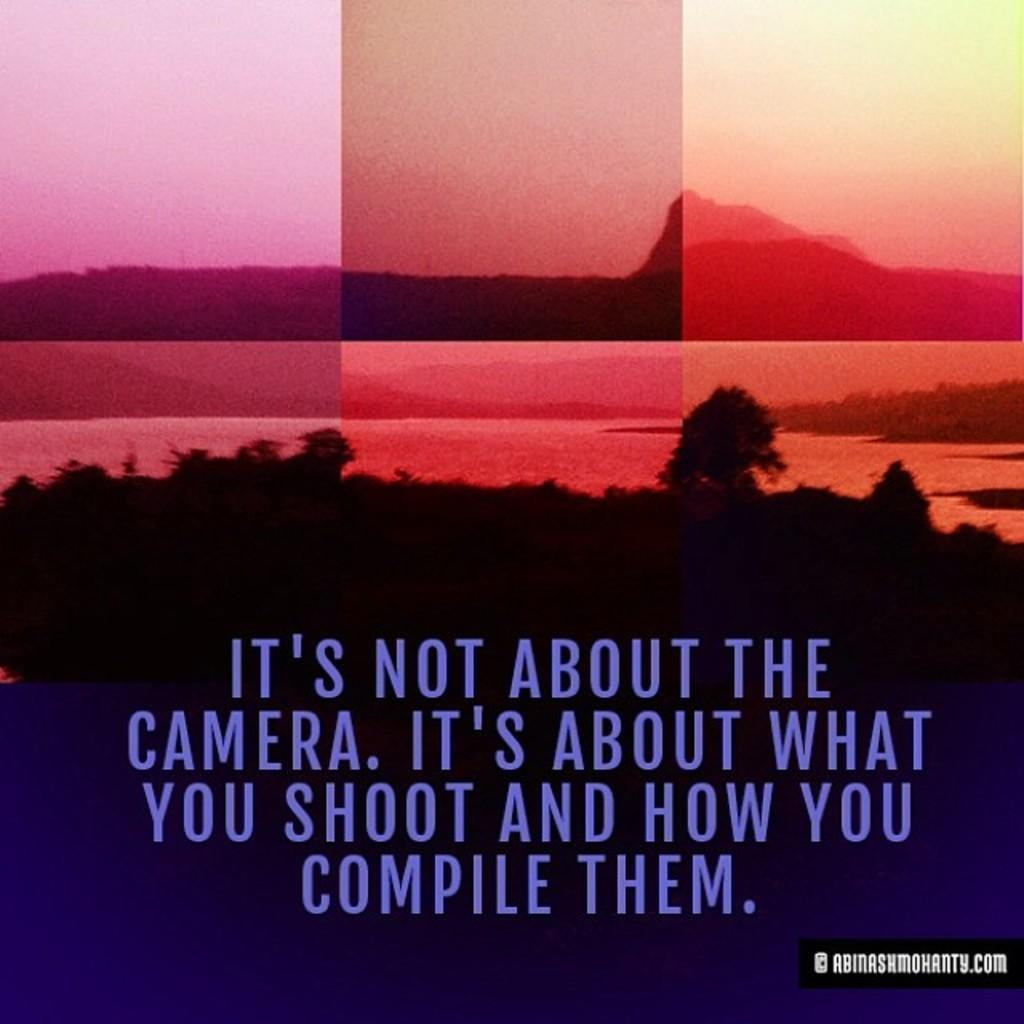<image>
Share a concise interpretation of the image provided. "It's not about the camera. It's about what you shoot and how you compile them"  with a scenic background that consists of a mountain, trees, and a lake. 